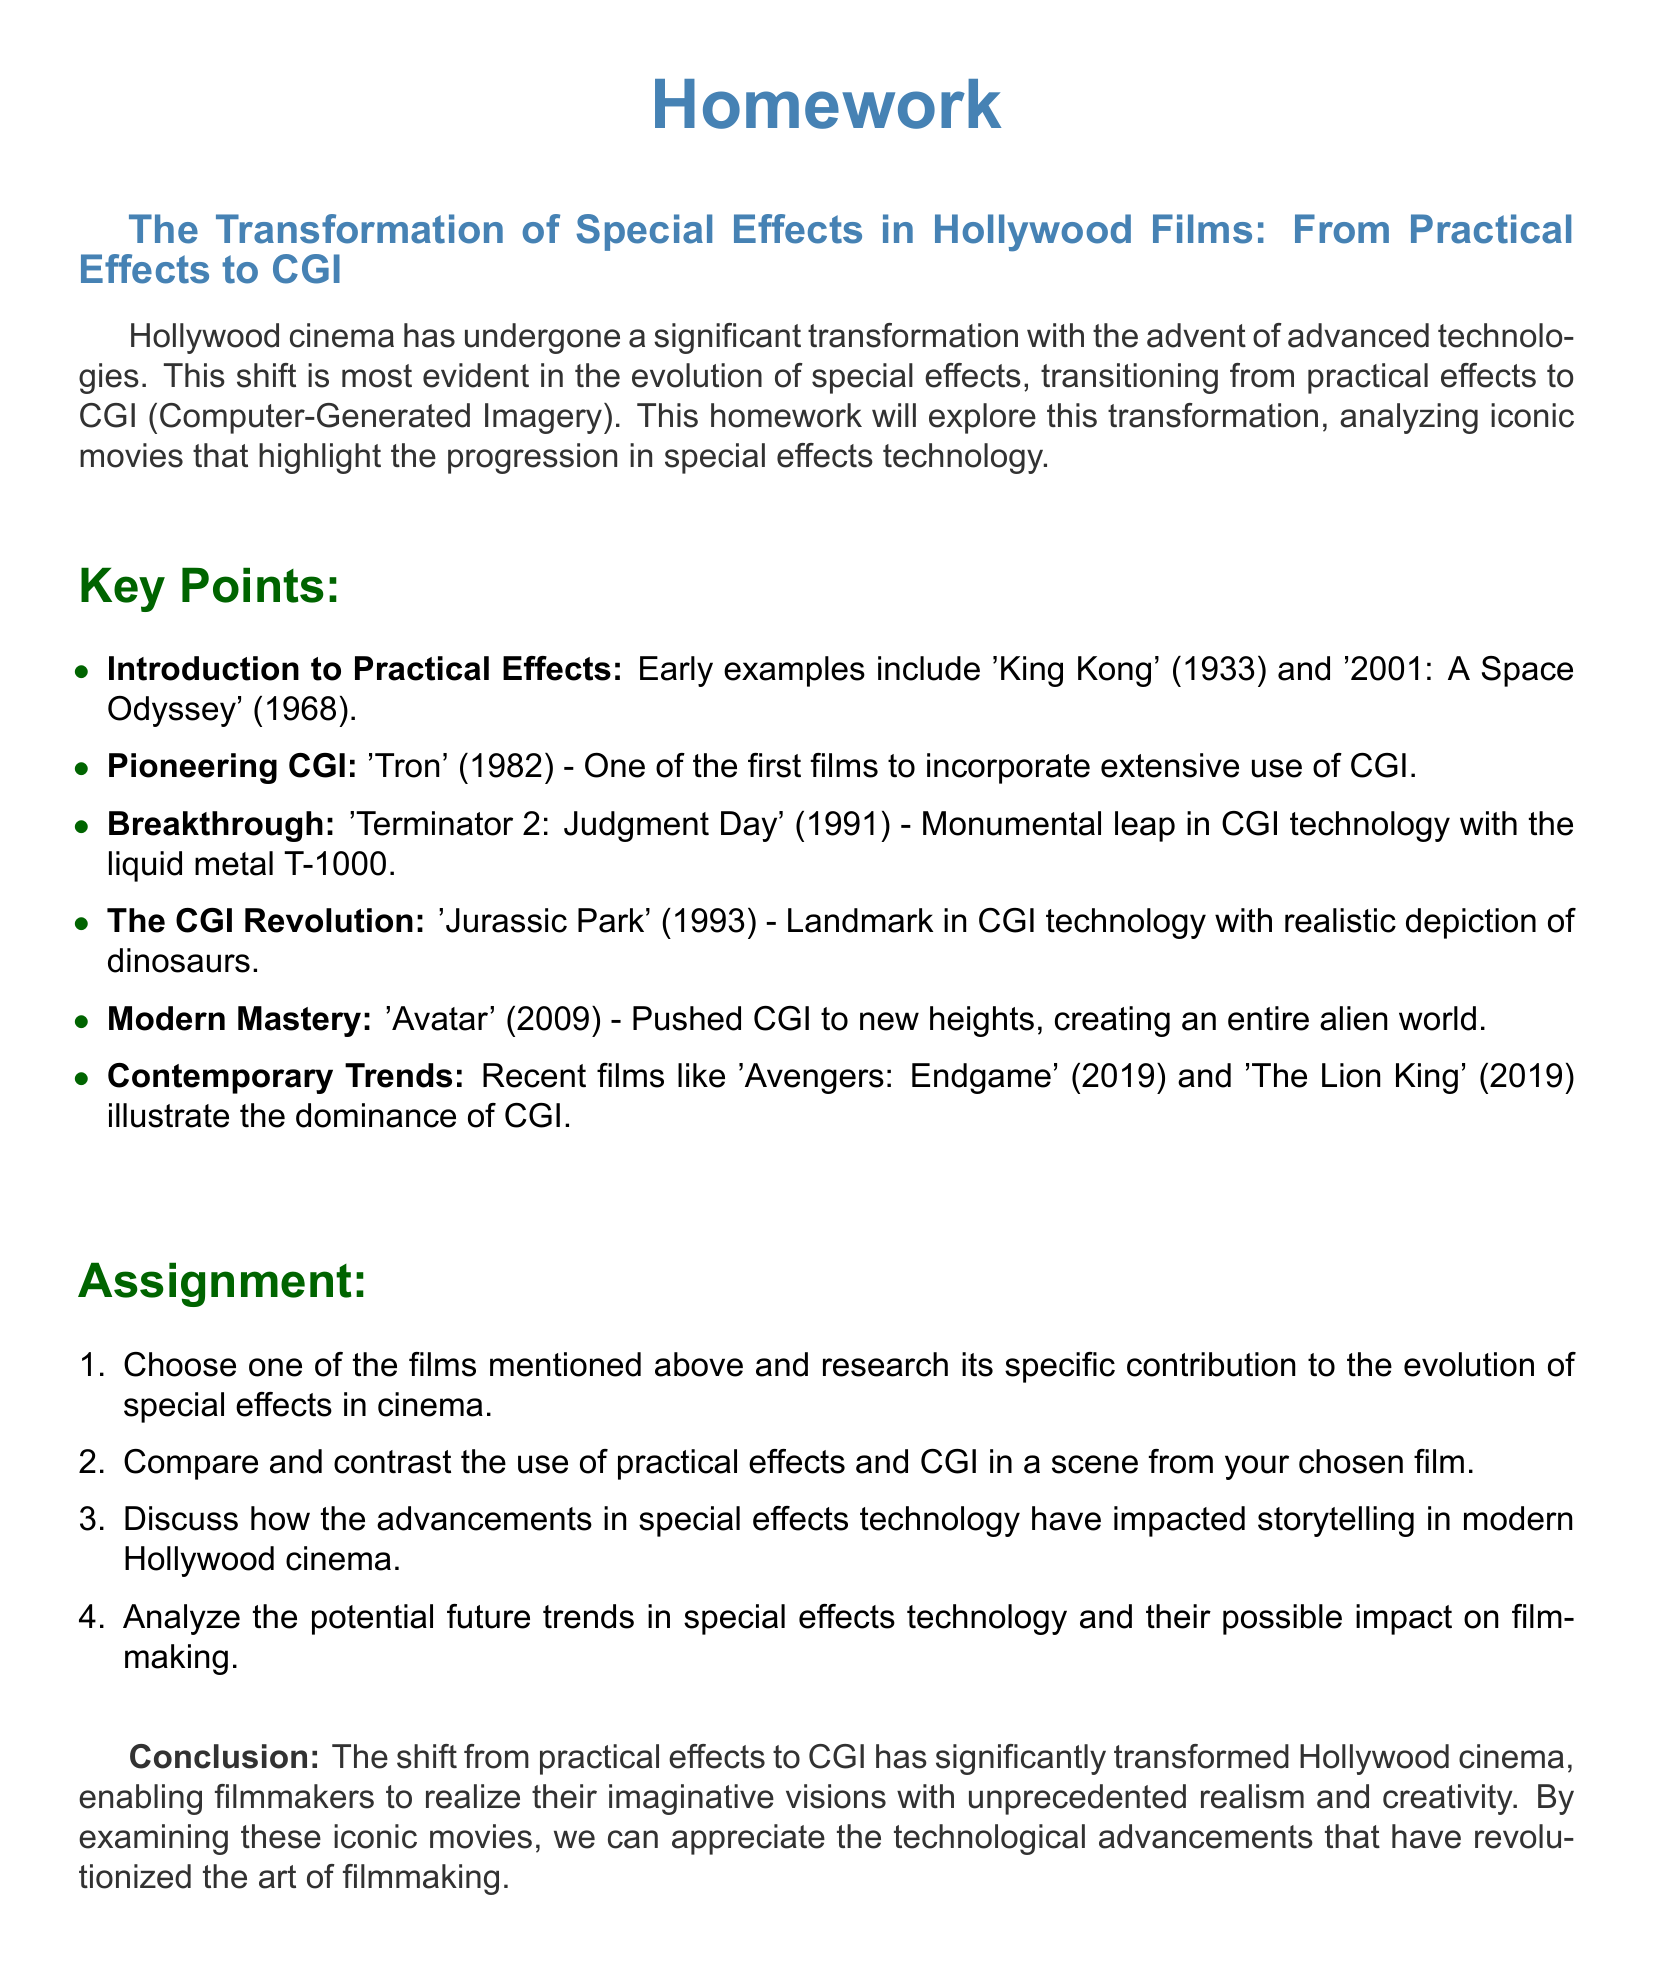What is the first film mentioned that utilized practical effects? The document states that early examples of practical effects include 'King Kong' (1933).
Answer: 'King Kong' (1933) Which film is noted for its extensive use of CGI from 1982? The document identifies 'Tron' (1982) as one of the first films to incorporate extensive use of CGI.
Answer: 'Tron' (1982) What significant breakthrough in CGI is associated with 'Terminator 2: Judgment Day'? The document mentions the liquid metal T-1000 as a monumental leap in CGI technology in 'Terminator 2: Judgment Day'.
Answer: liquid metal T-1000 In which year was 'Jurassic Park' released? The document lists 'Jurassic Park' as a landmark in CGI technology released in 1993.
Answer: 1993 What is the title of the film that pushed CGI to new heights in 2009? The document refers to 'Avatar' (2009) as a film that pushed CGI to new heights.
Answer: 'Avatar' (2009) Which recent films illustrate the dominance of CGI according to the document? The document cites 'Avengers: Endgame' (2019) and 'The Lion King' (2019) as examples of contemporary trends in CGI.
Answer: 'Avengers: Endgame' (2019) and 'The Lion King' (2019) What aspect of cinema does the document suggest has been significantly impacted by advancements in special effects technology? The document discusses how storytelling in modern Hollywood cinema has been impacted by advancements in special effects technology.
Answer: storytelling What type of effects does the document contrast with CGI? The document specifically contrasts practical effects with CGI in the context of special effects technology.
Answer: practical effects What genre of document is this homework focused on? The document focuses on the transformation of special effects in Hollywood films, which can be categorized as a film studies homework assignment.
Answer: film studies homework 